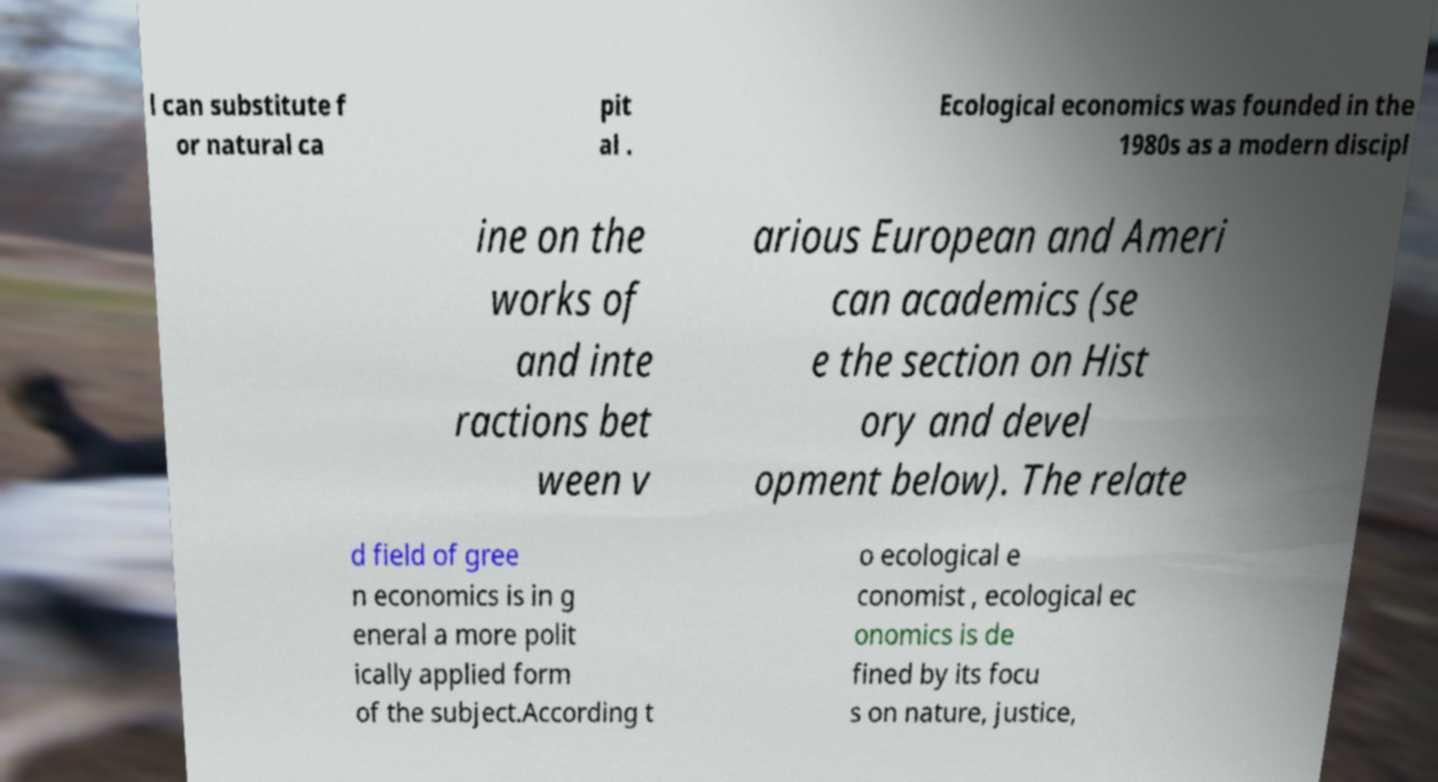Can you accurately transcribe the text from the provided image for me? l can substitute f or natural ca pit al . Ecological economics was founded in the 1980s as a modern discipl ine on the works of and inte ractions bet ween v arious European and Ameri can academics (se e the section on Hist ory and devel opment below). The relate d field of gree n economics is in g eneral a more polit ically applied form of the subject.According t o ecological e conomist , ecological ec onomics is de fined by its focu s on nature, justice, 